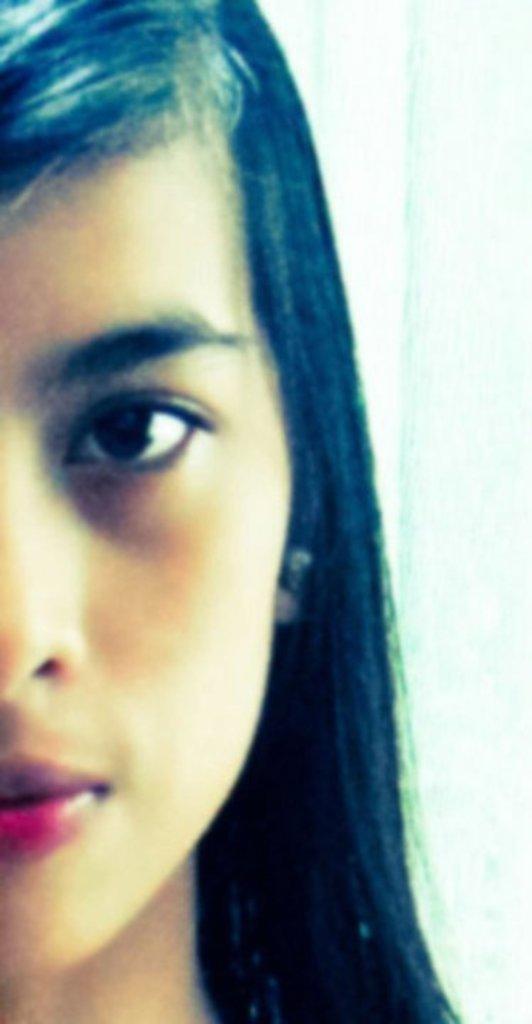Please provide a concise description of this image. In this image there is a woman at the left side of image. Background is in white color. 